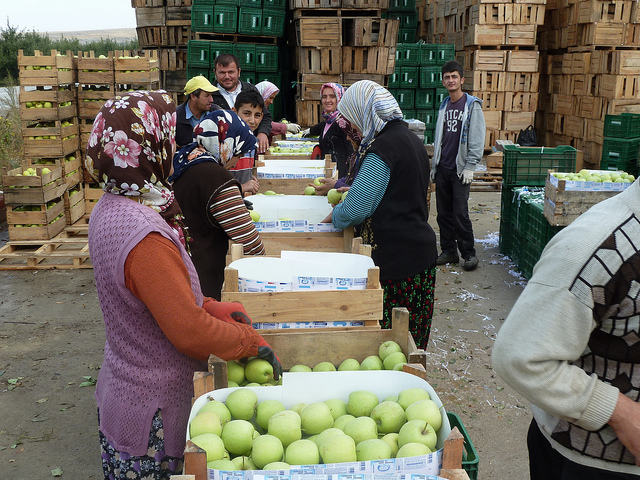Please identify all text content in this image. TCH 92 